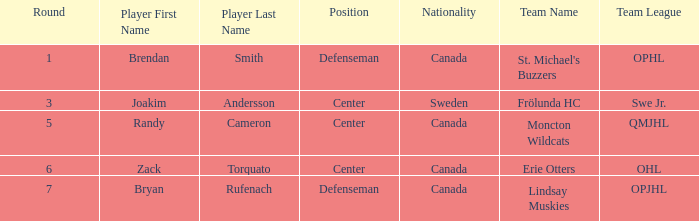Where does center Joakim Andersson come from? Sweden. 